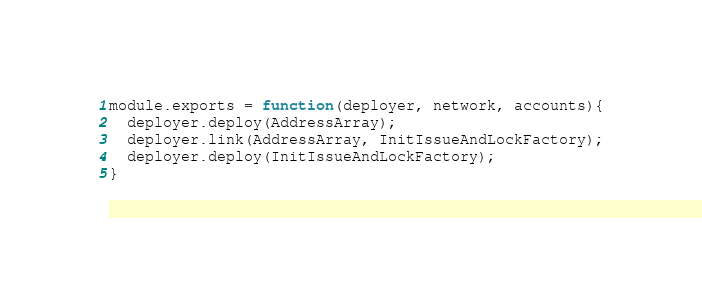<code> <loc_0><loc_0><loc_500><loc_500><_JavaScript_>module.exports = function(deployer, network, accounts){
  deployer.deploy(AddressArray);
  deployer.link(AddressArray, InitIssueAndLockFactory);
  deployer.deploy(InitIssueAndLockFactory);
}

</code> 